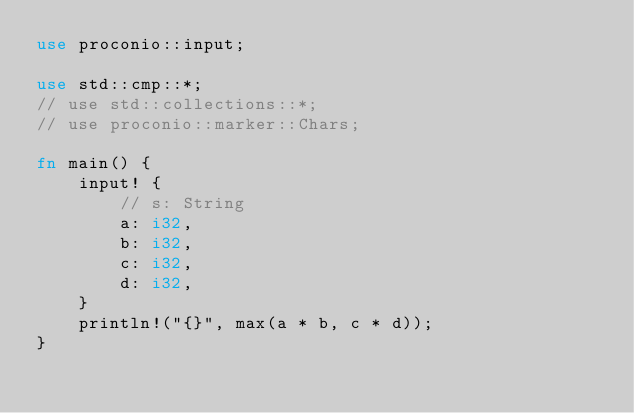<code> <loc_0><loc_0><loc_500><loc_500><_Rust_>use proconio::input;

use std::cmp::*;
// use std::collections::*;
// use proconio::marker::Chars;

fn main() {
    input! {
        // s: String
        a: i32,
        b: i32,
        c: i32,
        d: i32,
    }
    println!("{}", max(a * b, c * d));
}
</code> 